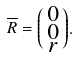Convert formula to latex. <formula><loc_0><loc_0><loc_500><loc_500>\overline { R } = \begin{psmallmatrix} 0 \\ 0 \\ r \end{psmallmatrix} .</formula> 